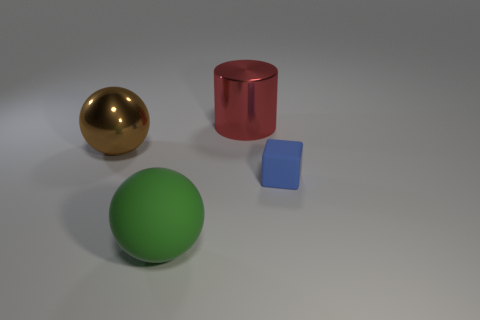Are there any big red cylinders in front of the blue object?
Your response must be concise. No. There is a tiny thing; is its shape the same as the big object that is left of the big rubber object?
Provide a succinct answer. No. How many other objects are the same material as the red cylinder?
Offer a very short reply. 1. There is a object that is on the right side of the large shiny object that is to the right of the large metal thing that is in front of the shiny cylinder; what is its color?
Ensure brevity in your answer.  Blue. There is a metallic object behind the big ball that is behind the tiny blue rubber cube; what is its shape?
Your answer should be very brief. Cylinder. Is the number of balls that are to the right of the large metal cylinder greater than the number of tiny yellow cylinders?
Offer a very short reply. No. Is the shape of the large thing in front of the brown thing the same as  the big brown shiny object?
Give a very brief answer. Yes. Is there a brown thing that has the same shape as the red object?
Offer a very short reply. No. How many things are big spheres in front of the large brown ball or small metal cylinders?
Offer a terse response. 1. Is the number of green spheres greater than the number of tiny cyan rubber balls?
Your answer should be very brief. Yes. 